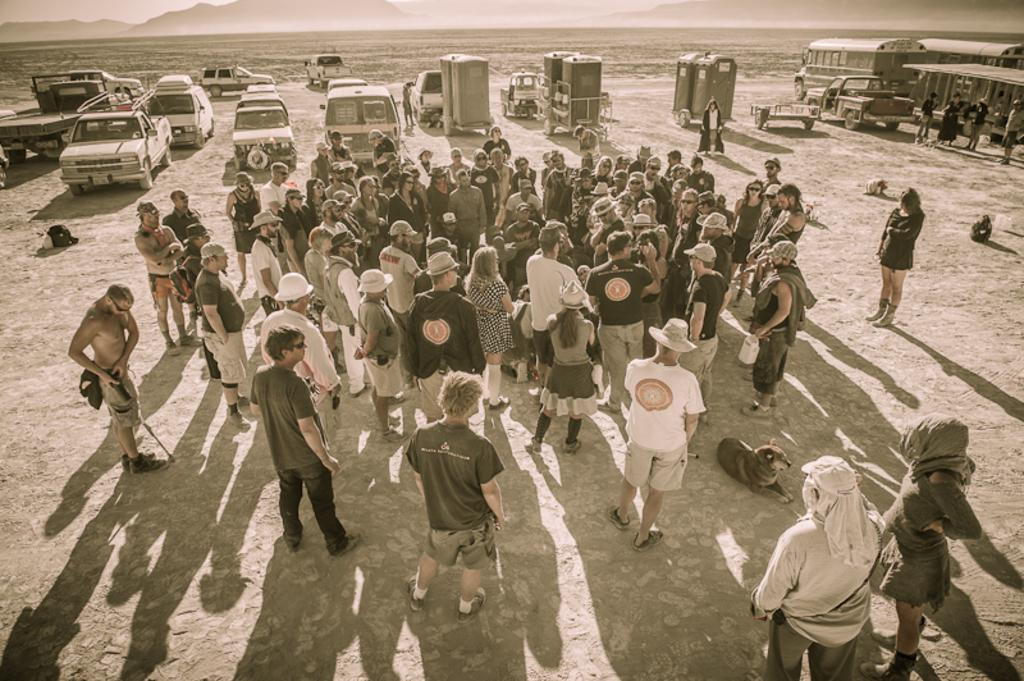What is the main subject in the foreground of the image? There is a crowd in the foreground of the image. What else can be seen on the ground in the image? There are fleets of vehicles on the ground. What is visible at the top of the image? The sky is visible at the top of the image. What can be inferred about the weather during the time the image was taken? The image appears to have been taken during a sunny day. Where is the hen located in the image? There is no hen present in the image. What type of toys can be seen in the image? There are no toys present in the image. 